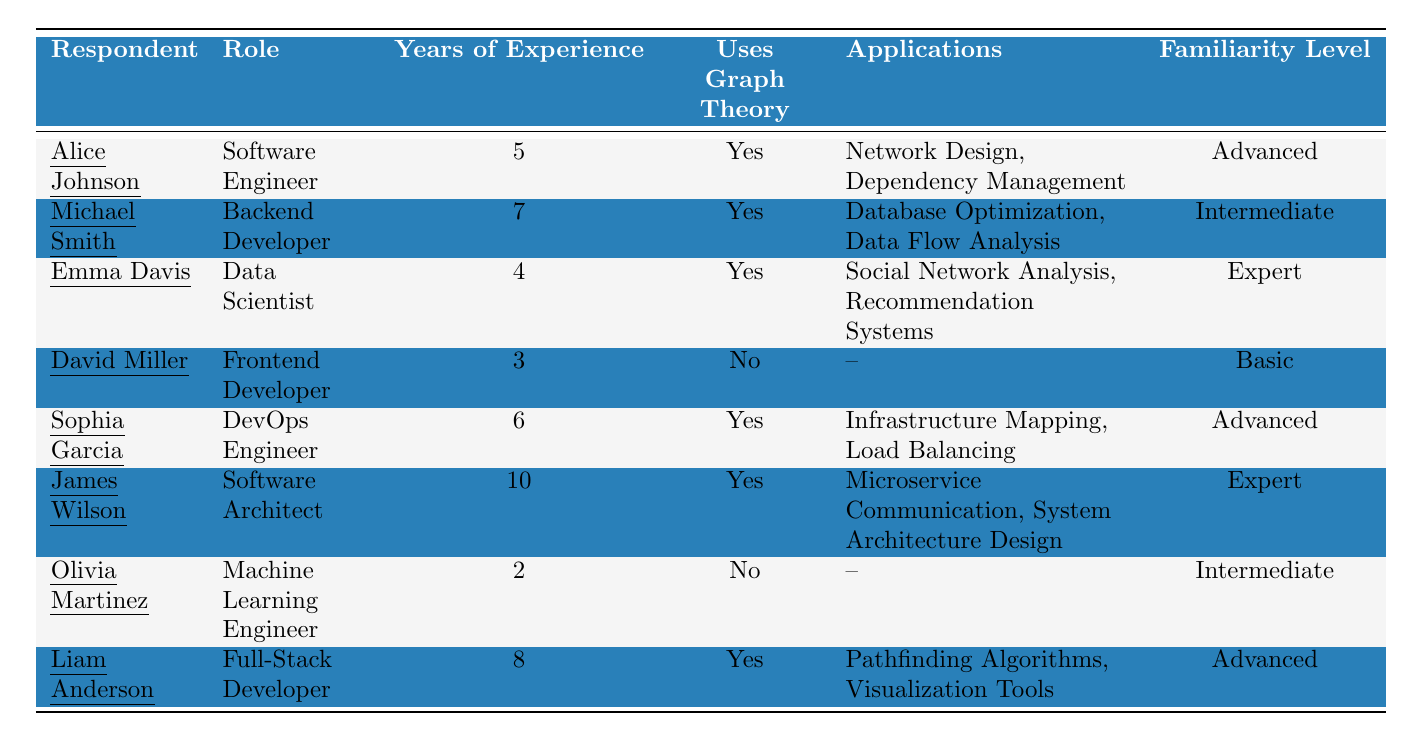What is the role of the respondent with the highest years of experience? Looking through the table, James Wilson has the highest years of experience, which is 10 years, and his role is "Software Architect."
Answer: Software Architect How many respondents use graph theory? By checking the "Uses Graph Theory" column, I count the respondents who have "Yes" marked next to them: Alice Johnson, Michael Smith, Emma Davis, Sophia Garcia, James Wilson, and Liam Anderson. This gives us a total of 6 respondents.
Answer: 6 What applications does Emma Davis use graph theory for? In the row for Emma Davis, it shows that she uses graph theory for "Social Network Analysis" and "Recommendation Systems."
Answer: Social Network Analysis, Recommendation Systems Is David Miller's familiarity level higher than that of Olivia Martinez? David Miller has a familiarity level of "Basic," while Olivia Martinez has "Intermediate." Comparing these two, "Intermediate" is higher than "Basic."
Answer: No How many developers with more than 5 years of experience use graph theory? I will check respondents with more than 5 years of experience: Michael Smith (7), Sophia Garcia (6), James Wilson (10), and Liam Anderson (8). All four of them use graph theory, which makes the count 4.
Answer: 4 Which respondent uses graph theory for "Load Balancing"? By inspecting the table, Sophia Garcia is the respondent who lists "Load Balancing" as one of the applications of graph theory.
Answer: Sophia Garcia What is the average years of experience among those who do not use graph theory? The respondents who do not use graph theory are David Miller (3 years) and Olivia Martinez (2 years). To find the average, we sum their years: 3 + 2 = 5. We then divide by 2 (the number of respondents): 5 / 2 = 2.5.
Answer: 2.5 Which familiarity level is more common among the respondents who use graph theory? The familiarity levels for those who use graph theory are Advanced (3), Intermediate (1), and Expert (2). Since Advanced appears most frequently, it is the more common level.
Answer: Advanced How many applications does Liam Anderson use graph theory for? Referring to Liam Anderson’s row, it shows two applications: "Pathfinding Algorithms" and "Visualization Tools." Therefore, he uses graph theory for 2 applications.
Answer: 2 Is it true that all respondents with less than 5 years of experience use graph theory? Looking at respondents with less than 5 years of experience, David Miller has 3 years and does not use graph theory, while Olivia Martinez has 2 and also does not use it. This means it is not true that they all use graph theory.
Answer: No 